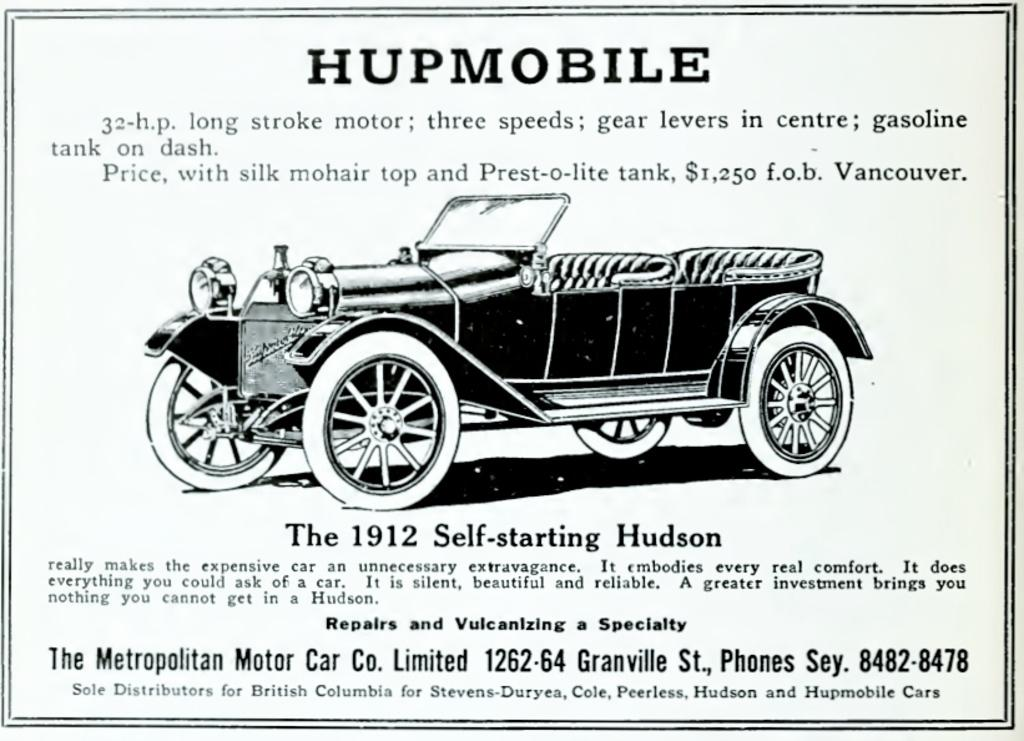What is the main subject of the image? The main subject of the image is an advertisement. What type of product or service is being advertised? The advertisement contains a car. What else can be seen in the advertisement besides the car? There is text present in the advertisement. What type of plastic material is used to make the car in the advertisement? The image does not provide information about the materials used to make the car in the advertisement. What religion is being promoted in the advertisement? There is no indication of any religious content or promotion in the advertisement. 